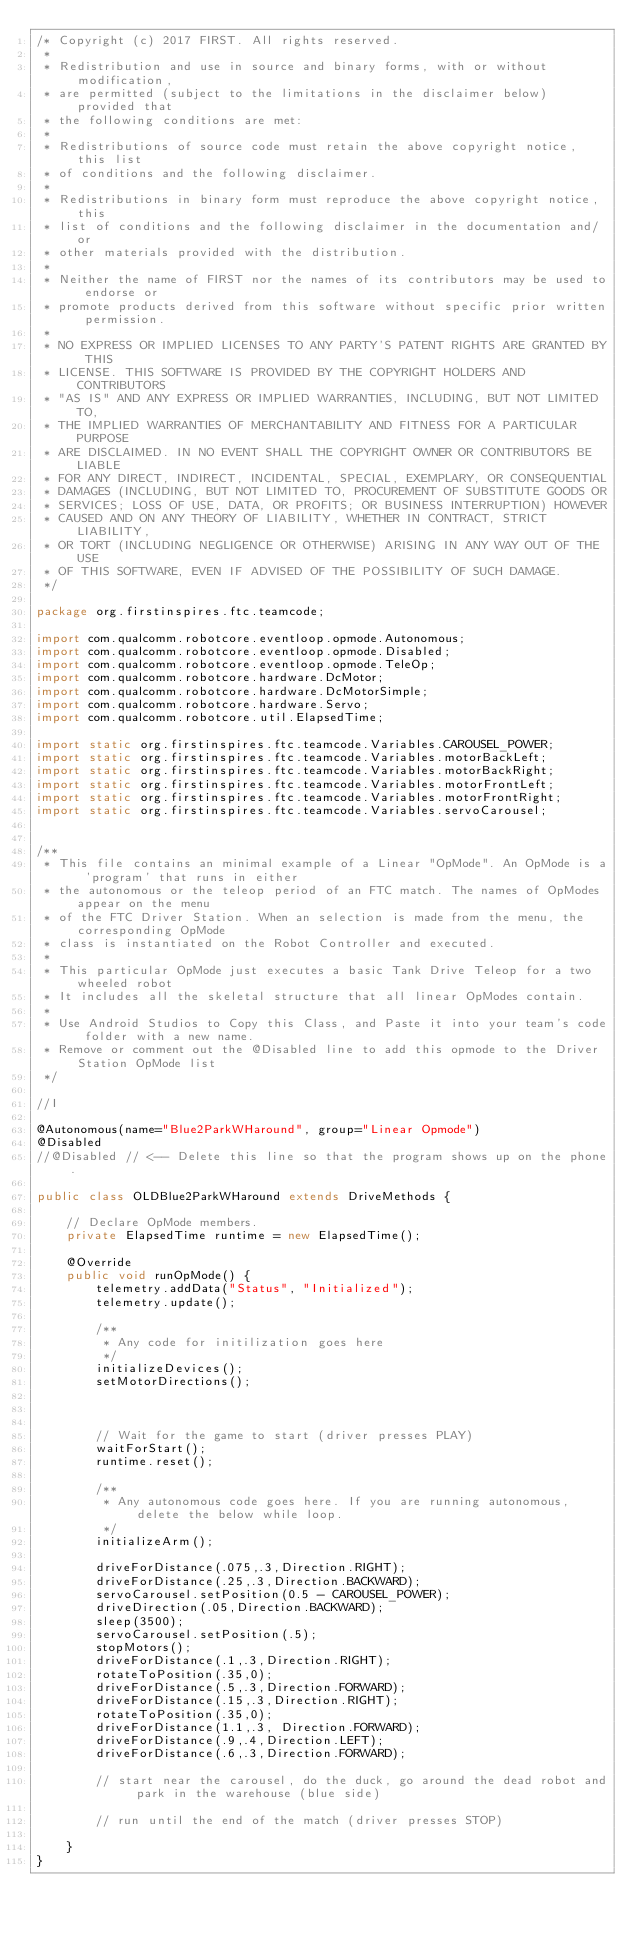Convert code to text. <code><loc_0><loc_0><loc_500><loc_500><_Java_>/* Copyright (c) 2017 FIRST. All rights reserved.
 *
 * Redistribution and use in source and binary forms, with or without modification,
 * are permitted (subject to the limitations in the disclaimer below) provided that
 * the following conditions are met:
 *
 * Redistributions of source code must retain the above copyright notice, this list
 * of conditions and the following disclaimer.
 *
 * Redistributions in binary form must reproduce the above copyright notice, this
 * list of conditions and the following disclaimer in the documentation and/or
 * other materials provided with the distribution.
 *
 * Neither the name of FIRST nor the names of its contributors may be used to endorse or
 * promote products derived from this software without specific prior written permission.
 *
 * NO EXPRESS OR IMPLIED LICENSES TO ANY PARTY'S PATENT RIGHTS ARE GRANTED BY THIS
 * LICENSE. THIS SOFTWARE IS PROVIDED BY THE COPYRIGHT HOLDERS AND CONTRIBUTORS
 * "AS IS" AND ANY EXPRESS OR IMPLIED WARRANTIES, INCLUDING, BUT NOT LIMITED TO,
 * THE IMPLIED WARRANTIES OF MERCHANTABILITY AND FITNESS FOR A PARTICULAR PURPOSE
 * ARE DISCLAIMED. IN NO EVENT SHALL THE COPYRIGHT OWNER OR CONTRIBUTORS BE LIABLE
 * FOR ANY DIRECT, INDIRECT, INCIDENTAL, SPECIAL, EXEMPLARY, OR CONSEQUENTIAL
 * DAMAGES (INCLUDING, BUT NOT LIMITED TO, PROCUREMENT OF SUBSTITUTE GOODS OR
 * SERVICES; LOSS OF USE, DATA, OR PROFITS; OR BUSINESS INTERRUPTION) HOWEVER
 * CAUSED AND ON ANY THEORY OF LIABILITY, WHETHER IN CONTRACT, STRICT LIABILITY,
 * OR TORT (INCLUDING NEGLIGENCE OR OTHERWISE) ARISING IN ANY WAY OUT OF THE USE
 * OF THIS SOFTWARE, EVEN IF ADVISED OF THE POSSIBILITY OF SUCH DAMAGE.
 */

package org.firstinspires.ftc.teamcode;

import com.qualcomm.robotcore.eventloop.opmode.Autonomous;
import com.qualcomm.robotcore.eventloop.opmode.Disabled;
import com.qualcomm.robotcore.eventloop.opmode.TeleOp;
import com.qualcomm.robotcore.hardware.DcMotor;
import com.qualcomm.robotcore.hardware.DcMotorSimple;
import com.qualcomm.robotcore.hardware.Servo;
import com.qualcomm.robotcore.util.ElapsedTime;

import static org.firstinspires.ftc.teamcode.Variables.CAROUSEL_POWER;
import static org.firstinspires.ftc.teamcode.Variables.motorBackLeft;
import static org.firstinspires.ftc.teamcode.Variables.motorBackRight;
import static org.firstinspires.ftc.teamcode.Variables.motorFrontLeft;
import static org.firstinspires.ftc.teamcode.Variables.motorFrontRight;
import static org.firstinspires.ftc.teamcode.Variables.servoCarousel;


/**
 * This file contains an minimal example of a Linear "OpMode". An OpMode is a 'program' that runs in either
 * the autonomous or the teleop period of an FTC match. The names of OpModes appear on the menu
 * of the FTC Driver Station. When an selection is made from the menu, the corresponding OpMode
 * class is instantiated on the Robot Controller and executed.
 *
 * This particular OpMode just executes a basic Tank Drive Teleop for a two wheeled robot
 * It includes all the skeletal structure that all linear OpModes contain.
 *
 * Use Android Studios to Copy this Class, and Paste it into your team's code folder with a new name.
 * Remove or comment out the @Disabled line to add this opmode to the Driver Station OpMode list
 */

//I

@Autonomous(name="Blue2ParkWHaround", group="Linear Opmode")
@Disabled
//@Disabled // <-- Delete this line so that the program shows up on the phone.

public class OLDBlue2ParkWHaround extends DriveMethods {

    // Declare OpMode members.
    private ElapsedTime runtime = new ElapsedTime();

    @Override
    public void runOpMode() {
        telemetry.addData("Status", "Initialized");
        telemetry.update();

        /**
         * Any code for initilization goes here
         */
        initializeDevices();
        setMotorDirections();



        // Wait for the game to start (driver presses PLAY)
        waitForStart();
        runtime.reset();

        /**
         * Any autonomous code goes here. If you are running autonomous, delete the below while loop.
         */
        initializeArm();

        driveForDistance(.075,.3,Direction.RIGHT);
        driveForDistance(.25,.3,Direction.BACKWARD);
        servoCarousel.setPosition(0.5 - CAROUSEL_POWER);
        driveDirection(.05,Direction.BACKWARD);
        sleep(3500);
        servoCarousel.setPosition(.5);
        stopMotors();
        driveForDistance(.1,.3,Direction.RIGHT);
        rotateToPosition(.35,0);
        driveForDistance(.5,.3,Direction.FORWARD);
        driveForDistance(.15,.3,Direction.RIGHT);
        rotateToPosition(.35,0);
        driveForDistance(1.1,.3, Direction.FORWARD);
        driveForDistance(.9,.4,Direction.LEFT);
        driveForDistance(.6,.3,Direction.FORWARD);

        // start near the carousel, do the duck, go around the dead robot and park in the warehouse (blue side)

        // run until the end of the match (driver presses STOP)

    }
}
</code> 